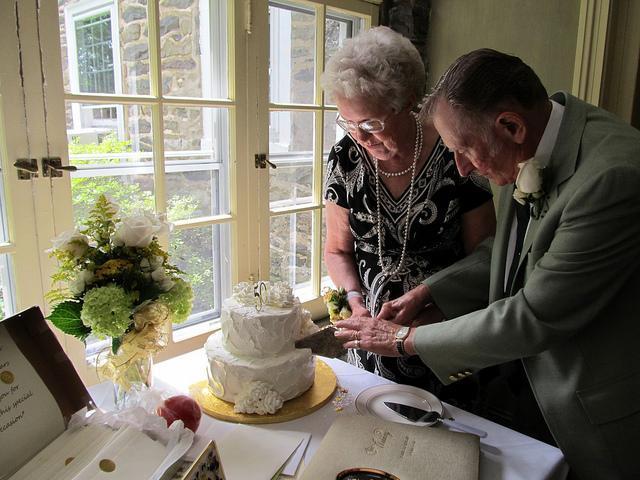How many people shown?
Give a very brief answer. 2. How many potted plants are there?
Give a very brief answer. 1. How many people are visible?
Give a very brief answer. 2. How many boats are there?
Give a very brief answer. 0. 